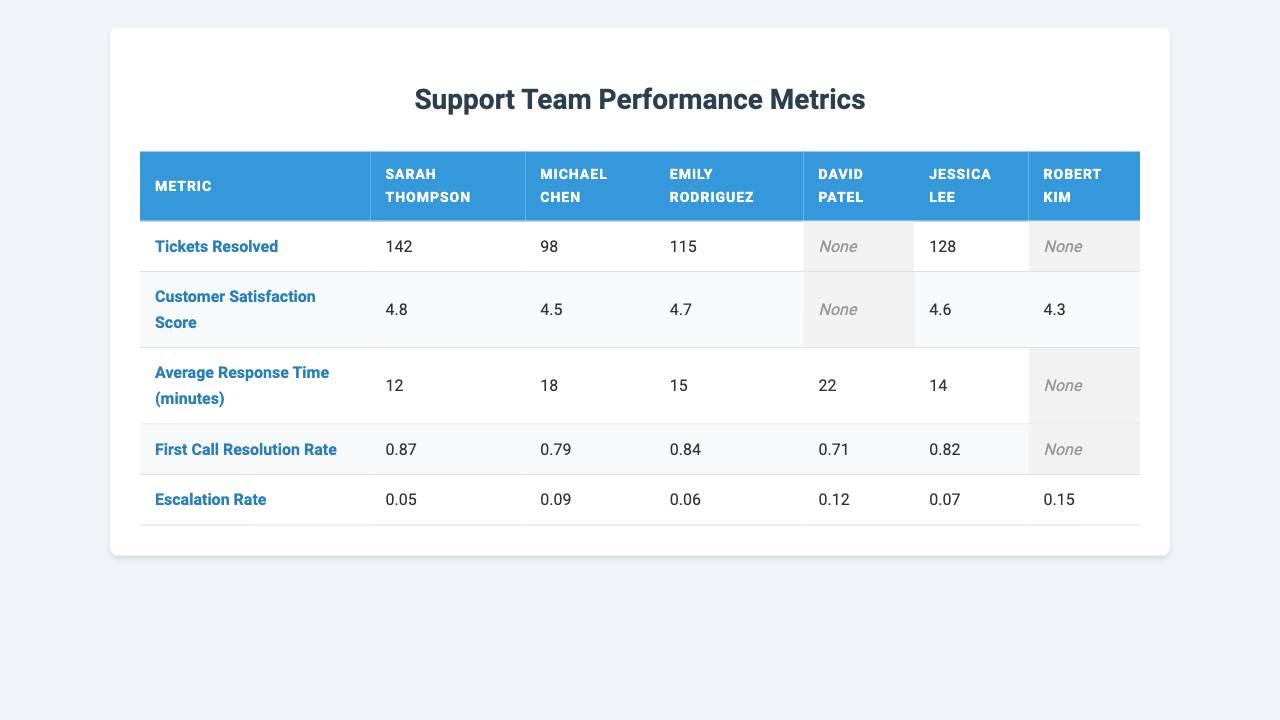What is the Customer Satisfaction Score for Sarah Thompson? The table indicates the Customer Satisfaction Score for Sarah Thompson, which is listed directly under her name. The score is 4.8.
Answer: 4.8 How many tickets did Emily Rodriguez resolve? Looking at the table, Emily Rodriguez has 115 tickets resolved shown in her row.
Answer: 115 What is the average response time for the support team? To find the average response time, we add the response times of the agents who have data: (12 + 18 + 15 + 22 + 14) = 81 minutes. There are 5 agents, so the average is 81 / 5 = 16.2 minutes.
Answer: 16.2 Did Jessica Lee have a higher First Call Resolution Rate than Michael Chen? Jessica Lee's First Call Resolution Rate is 0.82, while Michael Chen's is 0.79. Since 0.82 is greater than 0.79, the statement is true.
Answer: Yes Which agent has the highest number of tickets resolved? By comparing the total tickets resolved by all agents, Sarah Thompson has the highest with 142 tickets resolved, more than any other agent.
Answer: Sarah Thompson What is the difference in First Call Resolution Rate between Robert Kim and David Patel? Robert Kim's First Call Resolution Rate is missing (null), and David Patel's is 0.71. Since Robert's data is not available, the difference cannot be calculated.
Answer: N/A How many agents have an Escalation Rate higher than 0.10? From the table, David Patel and Robert Kim have Escalation Rates of 0.12 and 0.15, respectively. Thus, there are 2 agents with an Escalation Rate higher than 0.10.
Answer: 2 What is the total number of tickets resolved by agents with complete data? The agents with complete data are Sarah Thompson, Michael Chen, Emily Rodriguez, and Jessica Lee. Their tickets resolved are 142, 98, 115, and 128 respectively. The total number is (142 + 98 + 115 + 128) = 483 tickets.
Answer: 483 Is the average Customer Satisfaction Score of the agents with complete data above 4.5? For agents with complete data, the scores are 4.8, 4.5, 4.7, and 4.6. The average is (4.8 + 4.5 + 4.7 + 4.6) / 4 = 4.65, which is above 4.5.
Answer: Yes Which agent had the lowest Average Response Time? The Average Response Times for the agents with completed data are 12, 18, 15, and 14 minutes. Sarah Thompson has the lowest response time of 12 minutes.
Answer: Sarah Thompson What is the ratio of tickets resolved by Sarah Thompson to those resolved by Emily Rodriguez? Sarah Thompson resolved 142 tickets while Emily Rodriguez resolved 115 tickets. The ratio is 142:115, which can be simplified to approximately 1.24:1.
Answer: 1.24:1 